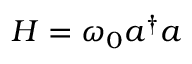Convert formula to latex. <formula><loc_0><loc_0><loc_500><loc_500>H = \omega _ { 0 } a ^ { \dag } a</formula> 